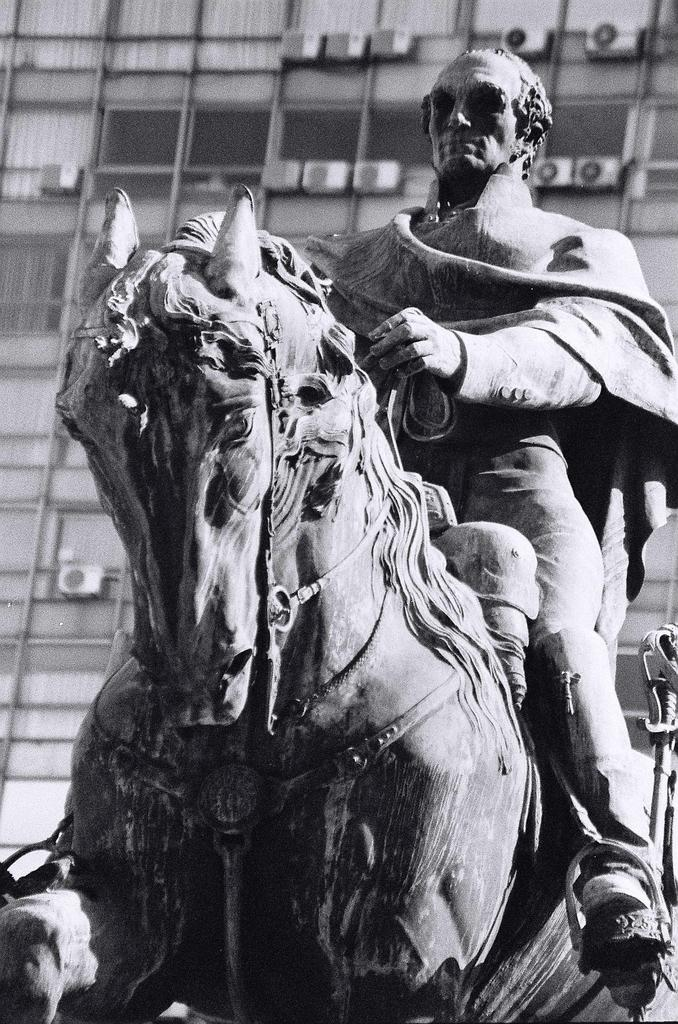What is the main subject of the statue in the image? The main subject of the statue in the image is a man. What is the man doing in the statue? The man is sitting on a horse in the statue. What can be seen in the background of the statue? There is a building visible behind the man in the statue. What type of insect can be seen crawling on the man's shoulder in the image? There is no insect present on the man's shoulder in the image. What hobbies does the man in the statue enjoy? The image does not provide information about the man's hobbies. 